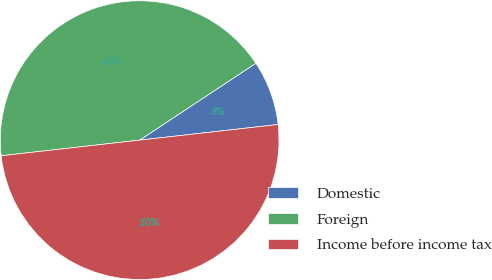<chart> <loc_0><loc_0><loc_500><loc_500><pie_chart><fcel>Domestic<fcel>Foreign<fcel>Income before income tax<nl><fcel>7.51%<fcel>42.49%<fcel>50.0%<nl></chart> 